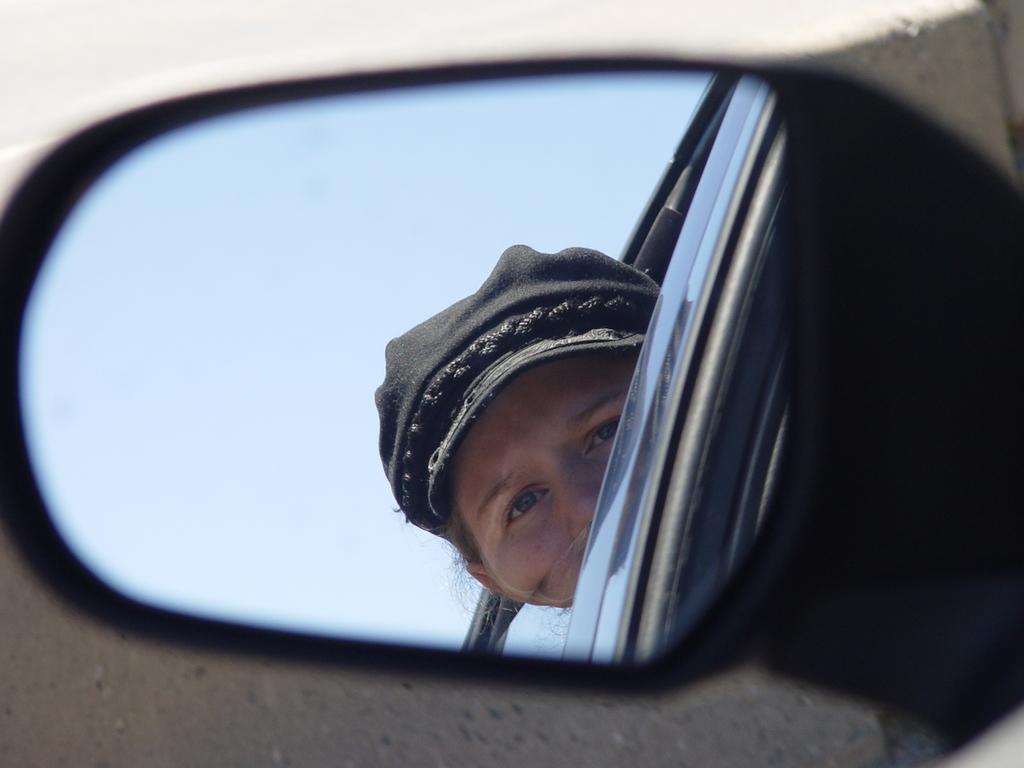Could you give a brief overview of what you see in this image? In the picture I can see the vehicle mirror in which I can see the reflection of a person wearing the cap and peeing their head through the window and I can see the sky in the background. 